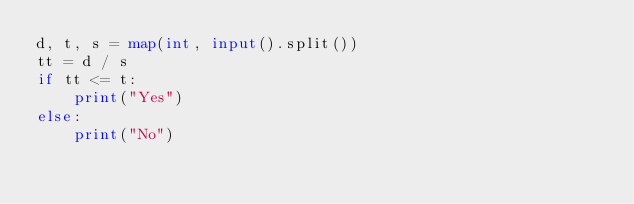Convert code to text. <code><loc_0><loc_0><loc_500><loc_500><_Python_>d, t, s = map(int, input().split())
tt = d / s
if tt <= t:
    print("Yes") 
else:
    print("No")

</code> 